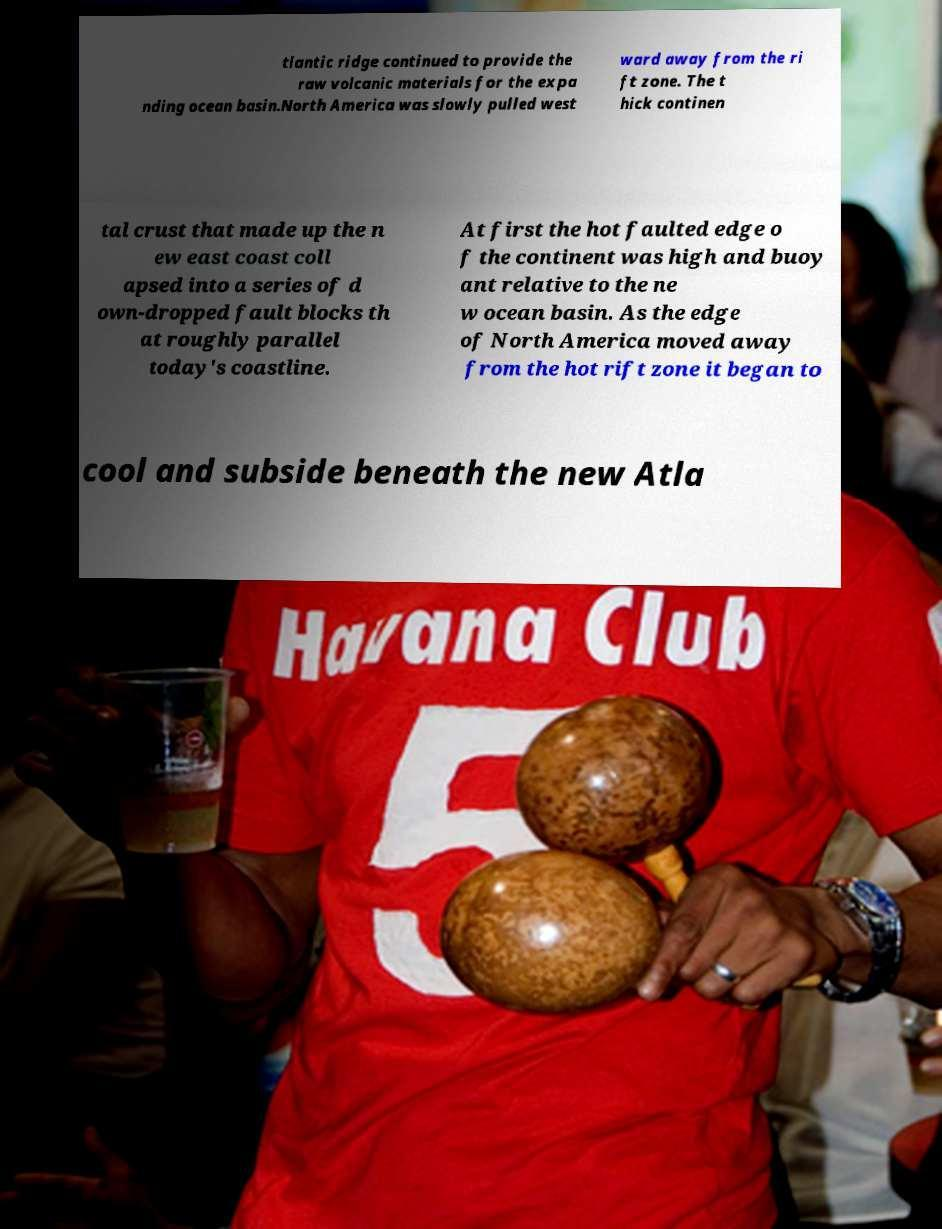Please identify and transcribe the text found in this image. tlantic ridge continued to provide the raw volcanic materials for the expa nding ocean basin.North America was slowly pulled west ward away from the ri ft zone. The t hick continen tal crust that made up the n ew east coast coll apsed into a series of d own-dropped fault blocks th at roughly parallel today's coastline. At first the hot faulted edge o f the continent was high and buoy ant relative to the ne w ocean basin. As the edge of North America moved away from the hot rift zone it began to cool and subside beneath the new Atla 